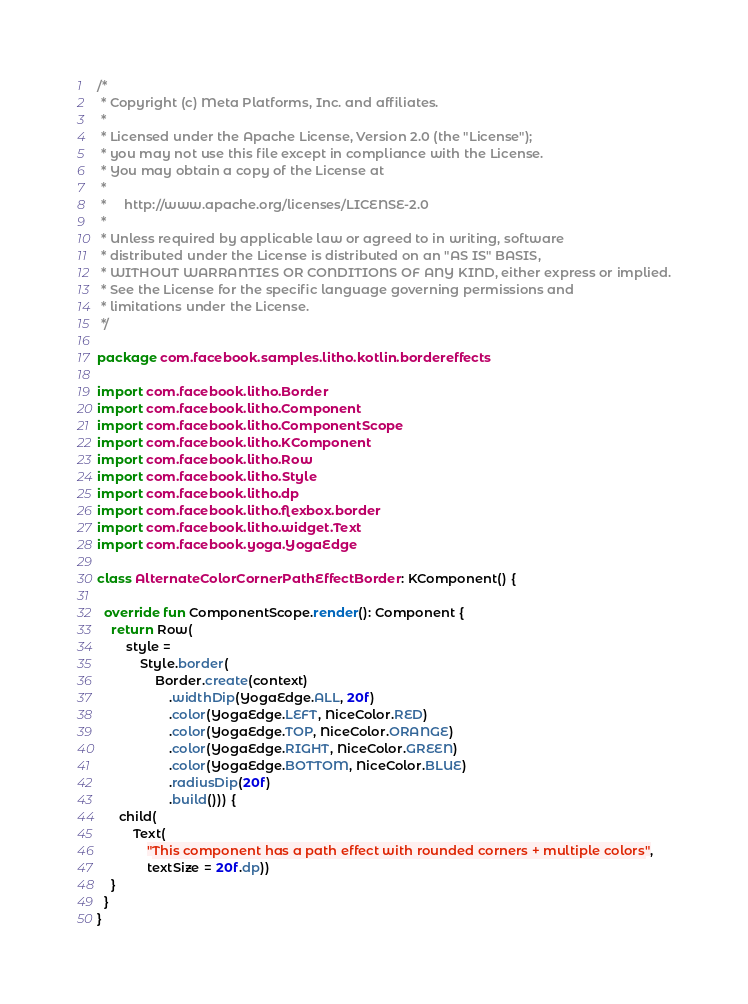<code> <loc_0><loc_0><loc_500><loc_500><_Kotlin_>/*
 * Copyright (c) Meta Platforms, Inc. and affiliates.
 *
 * Licensed under the Apache License, Version 2.0 (the "License");
 * you may not use this file except in compliance with the License.
 * You may obtain a copy of the License at
 *
 *     http://www.apache.org/licenses/LICENSE-2.0
 *
 * Unless required by applicable law or agreed to in writing, software
 * distributed under the License is distributed on an "AS IS" BASIS,
 * WITHOUT WARRANTIES OR CONDITIONS OF ANY KIND, either express or implied.
 * See the License for the specific language governing permissions and
 * limitations under the License.
 */

package com.facebook.samples.litho.kotlin.bordereffects

import com.facebook.litho.Border
import com.facebook.litho.Component
import com.facebook.litho.ComponentScope
import com.facebook.litho.KComponent
import com.facebook.litho.Row
import com.facebook.litho.Style
import com.facebook.litho.dp
import com.facebook.litho.flexbox.border
import com.facebook.litho.widget.Text
import com.facebook.yoga.YogaEdge

class AlternateColorCornerPathEffectBorder : KComponent() {

  override fun ComponentScope.render(): Component {
    return Row(
        style =
            Style.border(
                Border.create(context)
                    .widthDip(YogaEdge.ALL, 20f)
                    .color(YogaEdge.LEFT, NiceColor.RED)
                    .color(YogaEdge.TOP, NiceColor.ORANGE)
                    .color(YogaEdge.RIGHT, NiceColor.GREEN)
                    .color(YogaEdge.BOTTOM, NiceColor.BLUE)
                    .radiusDip(20f)
                    .build())) {
      child(
          Text(
              "This component has a path effect with rounded corners + multiple colors",
              textSize = 20f.dp))
    }
  }
}
</code> 